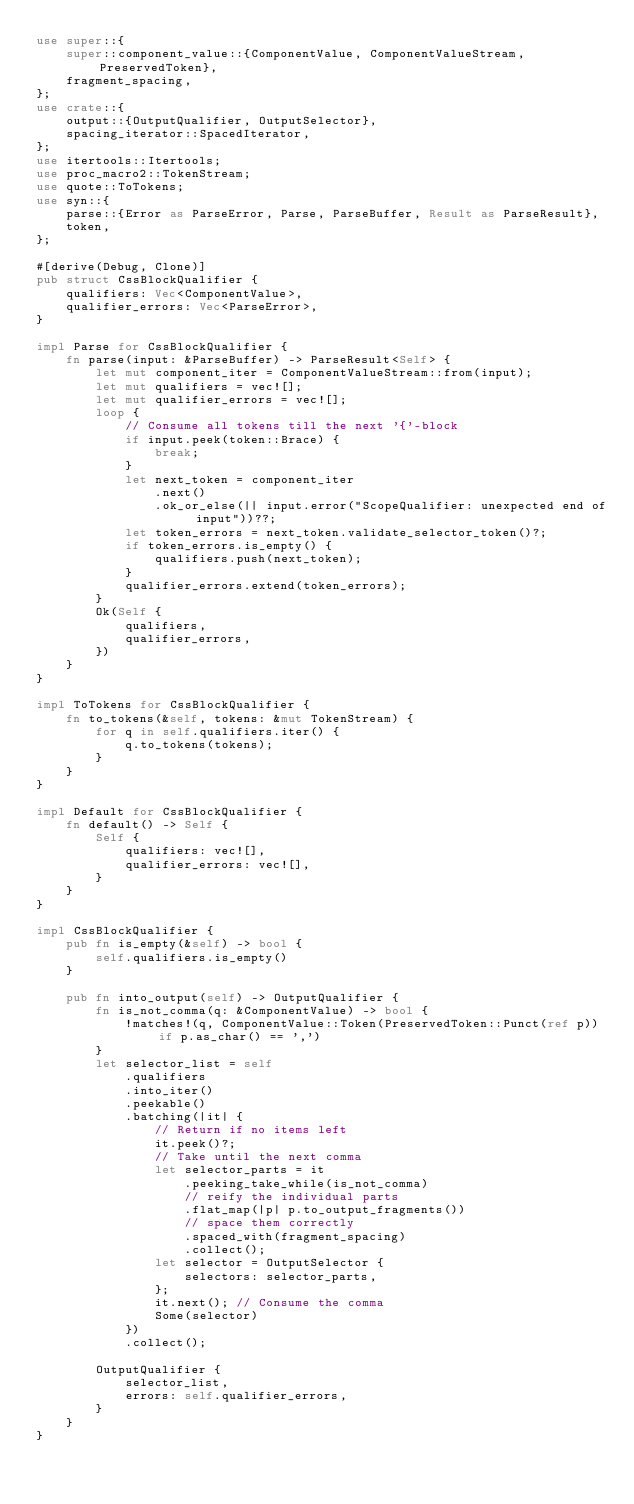Convert code to text. <code><loc_0><loc_0><loc_500><loc_500><_Rust_>use super::{
    super::component_value::{ComponentValue, ComponentValueStream, PreservedToken},
    fragment_spacing,
};
use crate::{
    output::{OutputQualifier, OutputSelector},
    spacing_iterator::SpacedIterator,
};
use itertools::Itertools;
use proc_macro2::TokenStream;
use quote::ToTokens;
use syn::{
    parse::{Error as ParseError, Parse, ParseBuffer, Result as ParseResult},
    token,
};

#[derive(Debug, Clone)]
pub struct CssBlockQualifier {
    qualifiers: Vec<ComponentValue>,
    qualifier_errors: Vec<ParseError>,
}

impl Parse for CssBlockQualifier {
    fn parse(input: &ParseBuffer) -> ParseResult<Self> {
        let mut component_iter = ComponentValueStream::from(input);
        let mut qualifiers = vec![];
        let mut qualifier_errors = vec![];
        loop {
            // Consume all tokens till the next '{'-block
            if input.peek(token::Brace) {
                break;
            }
            let next_token = component_iter
                .next()
                .ok_or_else(|| input.error("ScopeQualifier: unexpected end of input"))??;
            let token_errors = next_token.validate_selector_token()?;
            if token_errors.is_empty() {
                qualifiers.push(next_token);
            }
            qualifier_errors.extend(token_errors);
        }
        Ok(Self {
            qualifiers,
            qualifier_errors,
        })
    }
}

impl ToTokens for CssBlockQualifier {
    fn to_tokens(&self, tokens: &mut TokenStream) {
        for q in self.qualifiers.iter() {
            q.to_tokens(tokens);
        }
    }
}

impl Default for CssBlockQualifier {
    fn default() -> Self {
        Self {
            qualifiers: vec![],
            qualifier_errors: vec![],
        }
    }
}

impl CssBlockQualifier {
    pub fn is_empty(&self) -> bool {
        self.qualifiers.is_empty()
    }

    pub fn into_output(self) -> OutputQualifier {
        fn is_not_comma(q: &ComponentValue) -> bool {
            !matches!(q, ComponentValue::Token(PreservedToken::Punct(ref p)) if p.as_char() == ',')
        }
        let selector_list = self
            .qualifiers
            .into_iter()
            .peekable()
            .batching(|it| {
                // Return if no items left
                it.peek()?;
                // Take until the next comma
                let selector_parts = it
                    .peeking_take_while(is_not_comma)
                    // reify the individual parts
                    .flat_map(|p| p.to_output_fragments())
                    // space them correctly
                    .spaced_with(fragment_spacing)
                    .collect();
                let selector = OutputSelector {
                    selectors: selector_parts,
                };
                it.next(); // Consume the comma
                Some(selector)
            })
            .collect();

        OutputQualifier {
            selector_list,
            errors: self.qualifier_errors,
        }
    }
}
</code> 